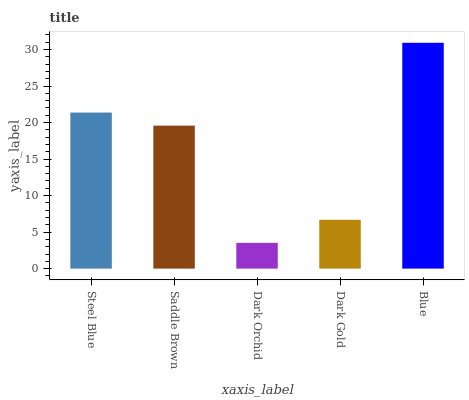Is Dark Orchid the minimum?
Answer yes or no. Yes. Is Blue the maximum?
Answer yes or no. Yes. Is Saddle Brown the minimum?
Answer yes or no. No. Is Saddle Brown the maximum?
Answer yes or no. No. Is Steel Blue greater than Saddle Brown?
Answer yes or no. Yes. Is Saddle Brown less than Steel Blue?
Answer yes or no. Yes. Is Saddle Brown greater than Steel Blue?
Answer yes or no. No. Is Steel Blue less than Saddle Brown?
Answer yes or no. No. Is Saddle Brown the high median?
Answer yes or no. Yes. Is Saddle Brown the low median?
Answer yes or no. Yes. Is Steel Blue the high median?
Answer yes or no. No. Is Dark Orchid the low median?
Answer yes or no. No. 